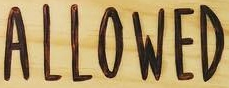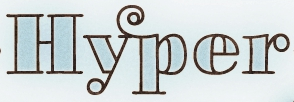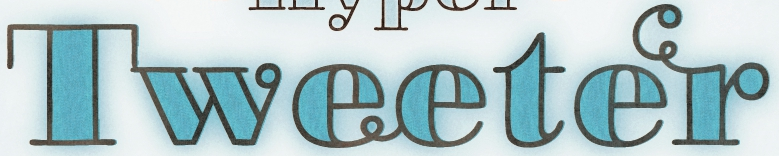What text is displayed in these images sequentially, separated by a semicolon? ALLOWED; Hyper; Tweeter 